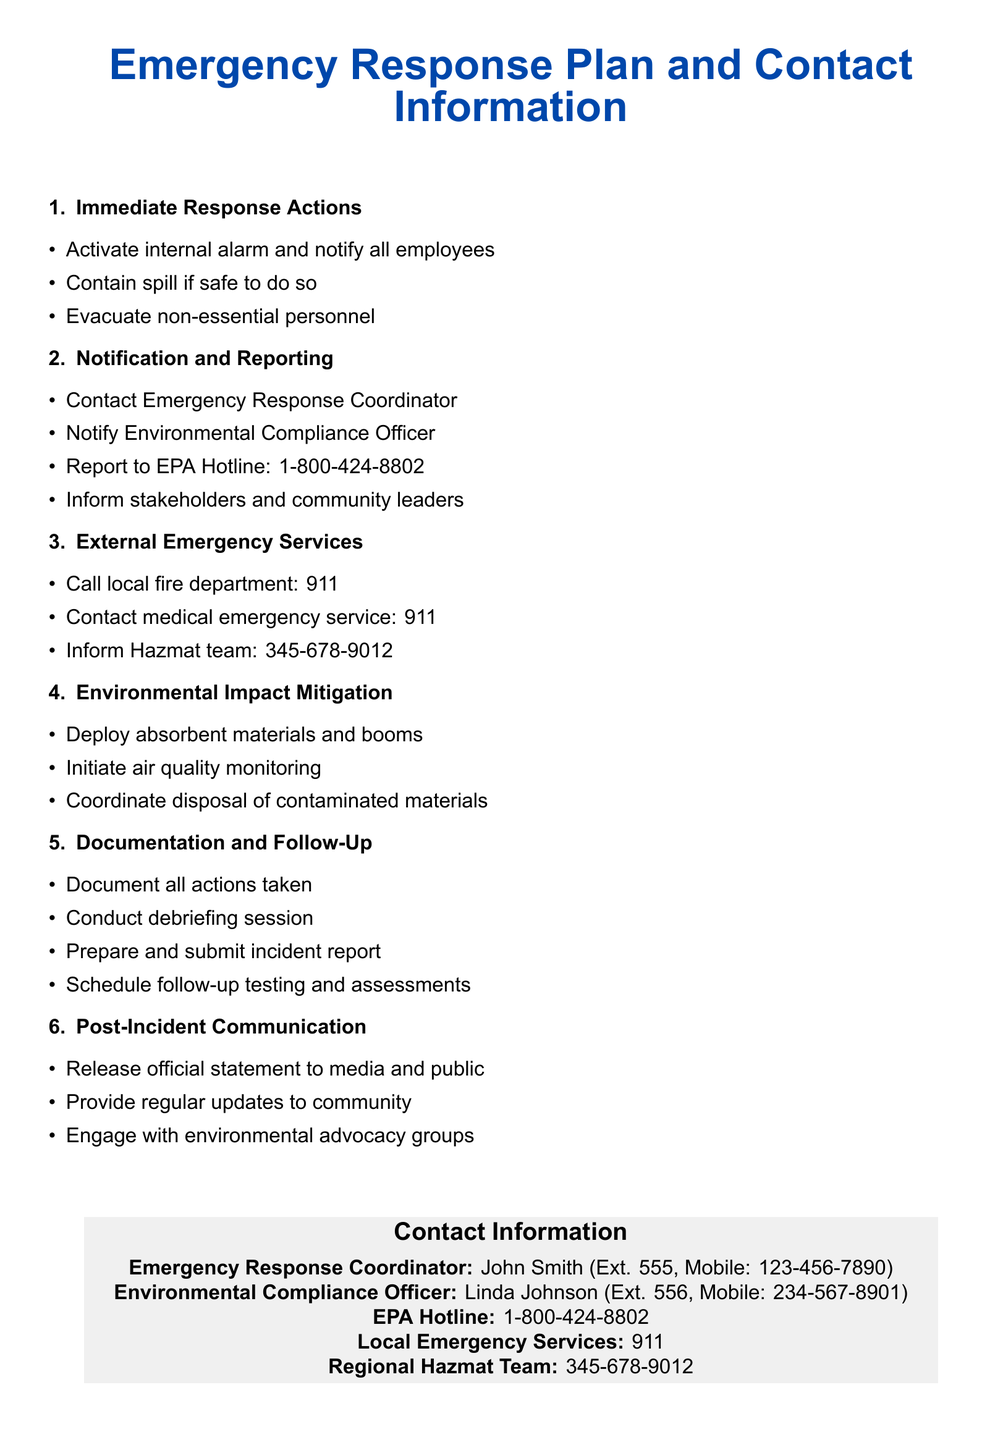what is the title of the document? The title is stated at the beginning of the document, indicating its contents.
Answer: Emergency Response Plan and Contact Information who is the Emergency Response Coordinator? The document lists the name and contact of the individual responsible for emergency response.
Answer: John Smith what is the contact extension for the Environmental Compliance Officer? The document specifies the extension number for the Environmental Compliance Officer's contact.
Answer: 556 how should spills be contained? The document provides guidance on actions to take during an environmental incident, specifically regarding spills.
Answer: If safe to do so what number should be called for local emergency services? The document indicates the number to reach local emergency services.
Answer: 911 name a measure for Environmental Impact Mitigation. The document includes a list of actions to mitigate environmental impact following an incident.
Answer: Deploy absorbent materials and booms what is one action to take for post-incident communication? The document outlines steps to follow for communication after an environmental incident.
Answer: Release official statement to media and public how many steps are listed under Documentation and Follow-Up? The document mentions a specific number of actions related to documentation and follow-up after an incident.
Answer: Four 